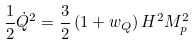Convert formula to latex. <formula><loc_0><loc_0><loc_500><loc_500>\frac { 1 } { 2 } \dot { Q } ^ { 2 } = \frac { 3 } { 2 } \left ( 1 + w _ { Q } \right ) H ^ { 2 } M _ { p } ^ { 2 }</formula> 